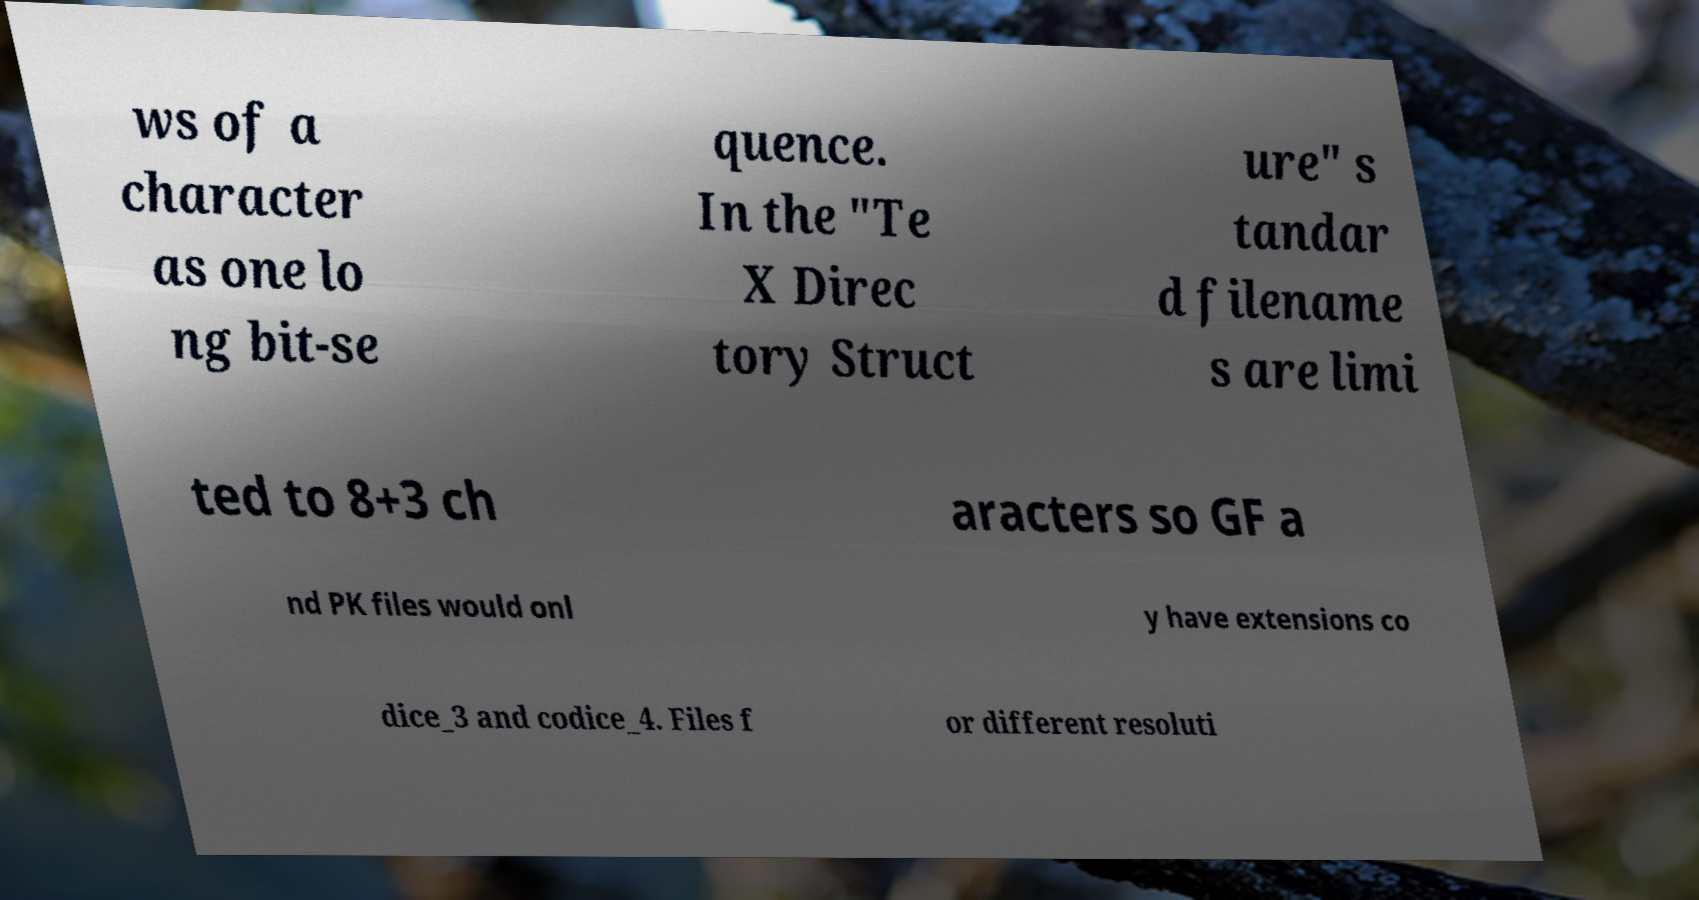Could you extract and type out the text from this image? ws of a character as one lo ng bit-se quence. In the "Te X Direc tory Struct ure" s tandar d filename s are limi ted to 8+3 ch aracters so GF a nd PK files would onl y have extensions co dice_3 and codice_4. Files f or different resoluti 